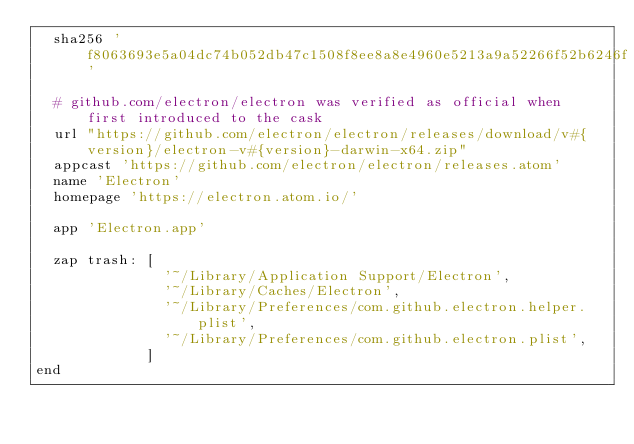<code> <loc_0><loc_0><loc_500><loc_500><_Ruby_>  sha256 'f8063693e5a04dc74b052db47c1508f8ee8a8e4960e5213a9a52266f52b6246f'

  # github.com/electron/electron was verified as official when first introduced to the cask
  url "https://github.com/electron/electron/releases/download/v#{version}/electron-v#{version}-darwin-x64.zip"
  appcast 'https://github.com/electron/electron/releases.atom'
  name 'Electron'
  homepage 'https://electron.atom.io/'

  app 'Electron.app'

  zap trash: [
               '~/Library/Application Support/Electron',
               '~/Library/Caches/Electron',
               '~/Library/Preferences/com.github.electron.helper.plist',
               '~/Library/Preferences/com.github.electron.plist',
             ]
end
</code> 